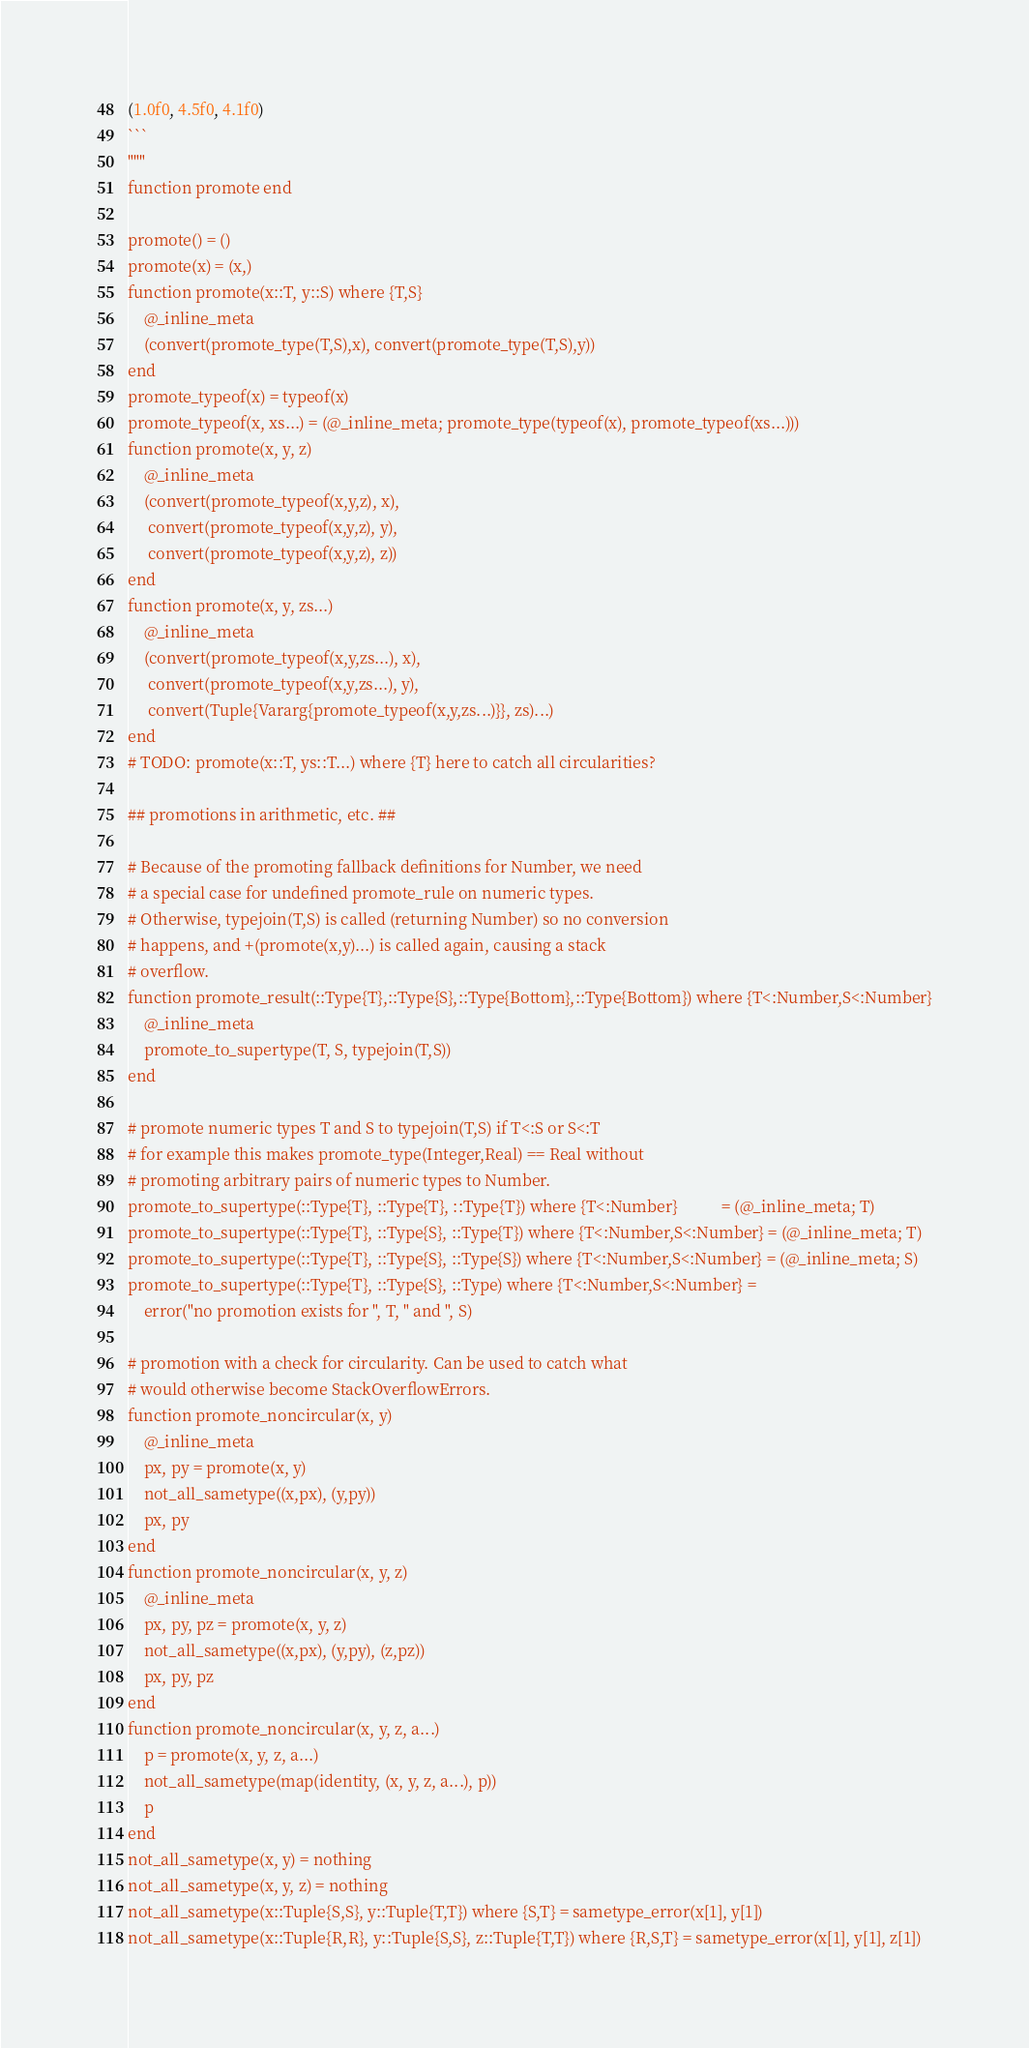<code> <loc_0><loc_0><loc_500><loc_500><_Julia_>(1.0f0, 4.5f0, 4.1f0)
```
"""
function promote end

promote() = ()
promote(x) = (x,)
function promote(x::T, y::S) where {T,S}
    @_inline_meta
    (convert(promote_type(T,S),x), convert(promote_type(T,S),y))
end
promote_typeof(x) = typeof(x)
promote_typeof(x, xs...) = (@_inline_meta; promote_type(typeof(x), promote_typeof(xs...)))
function promote(x, y, z)
    @_inline_meta
    (convert(promote_typeof(x,y,z), x),
     convert(promote_typeof(x,y,z), y),
     convert(promote_typeof(x,y,z), z))
end
function promote(x, y, zs...)
    @_inline_meta
    (convert(promote_typeof(x,y,zs...), x),
     convert(promote_typeof(x,y,zs...), y),
     convert(Tuple{Vararg{promote_typeof(x,y,zs...)}}, zs)...)
end
# TODO: promote(x::T, ys::T...) where {T} here to catch all circularities?

## promotions in arithmetic, etc. ##

# Because of the promoting fallback definitions for Number, we need
# a special case for undefined promote_rule on numeric types.
# Otherwise, typejoin(T,S) is called (returning Number) so no conversion
# happens, and +(promote(x,y)...) is called again, causing a stack
# overflow.
function promote_result(::Type{T},::Type{S},::Type{Bottom},::Type{Bottom}) where {T<:Number,S<:Number}
    @_inline_meta
    promote_to_supertype(T, S, typejoin(T,S))
end

# promote numeric types T and S to typejoin(T,S) if T<:S or S<:T
# for example this makes promote_type(Integer,Real) == Real without
# promoting arbitrary pairs of numeric types to Number.
promote_to_supertype(::Type{T}, ::Type{T}, ::Type{T}) where {T<:Number}           = (@_inline_meta; T)
promote_to_supertype(::Type{T}, ::Type{S}, ::Type{T}) where {T<:Number,S<:Number} = (@_inline_meta; T)
promote_to_supertype(::Type{T}, ::Type{S}, ::Type{S}) where {T<:Number,S<:Number} = (@_inline_meta; S)
promote_to_supertype(::Type{T}, ::Type{S}, ::Type) where {T<:Number,S<:Number} =
    error("no promotion exists for ", T, " and ", S)

# promotion with a check for circularity. Can be used to catch what
# would otherwise become StackOverflowErrors.
function promote_noncircular(x, y)
    @_inline_meta
    px, py = promote(x, y)
    not_all_sametype((x,px), (y,py))
    px, py
end
function promote_noncircular(x, y, z)
    @_inline_meta
    px, py, pz = promote(x, y, z)
    not_all_sametype((x,px), (y,py), (z,pz))
    px, py, pz
end
function promote_noncircular(x, y, z, a...)
    p = promote(x, y, z, a...)
    not_all_sametype(map(identity, (x, y, z, a...), p))
    p
end
not_all_sametype(x, y) = nothing
not_all_sametype(x, y, z) = nothing
not_all_sametype(x::Tuple{S,S}, y::Tuple{T,T}) where {S,T} = sametype_error(x[1], y[1])
not_all_sametype(x::Tuple{R,R}, y::Tuple{S,S}, z::Tuple{T,T}) where {R,S,T} = sametype_error(x[1], y[1], z[1])</code> 